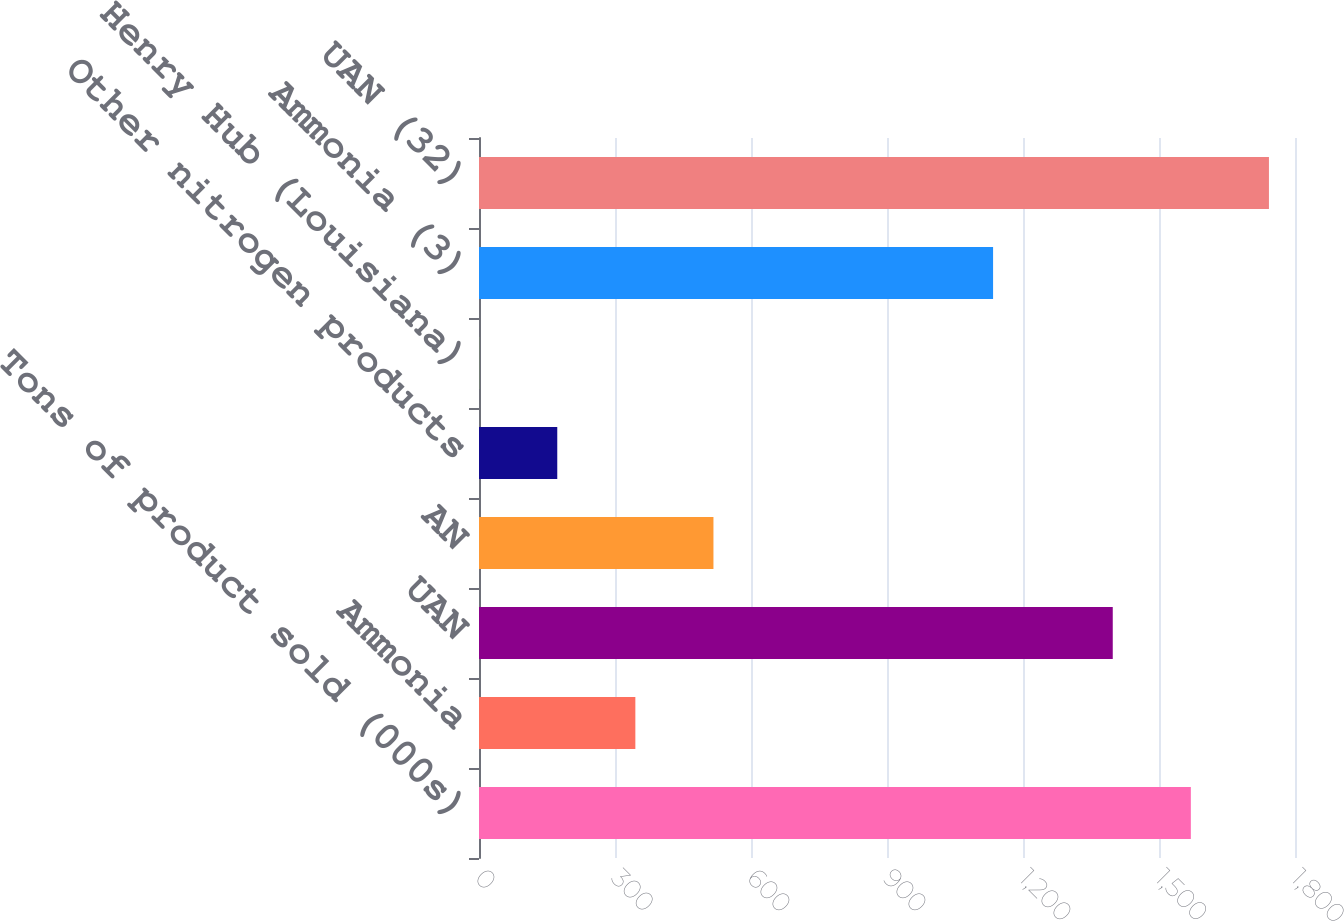<chart> <loc_0><loc_0><loc_500><loc_500><bar_chart><fcel>Tons of product sold (000s)<fcel>Ammonia<fcel>UAN<fcel>AN<fcel>Other nitrogen products<fcel>Henry Hub (Louisiana)<fcel>Ammonia (3)<fcel>UAN (32)<nl><fcel>1570.26<fcel>344.9<fcel>1398<fcel>517.16<fcel>172.64<fcel>0.38<fcel>1134<fcel>1742.52<nl></chart> 